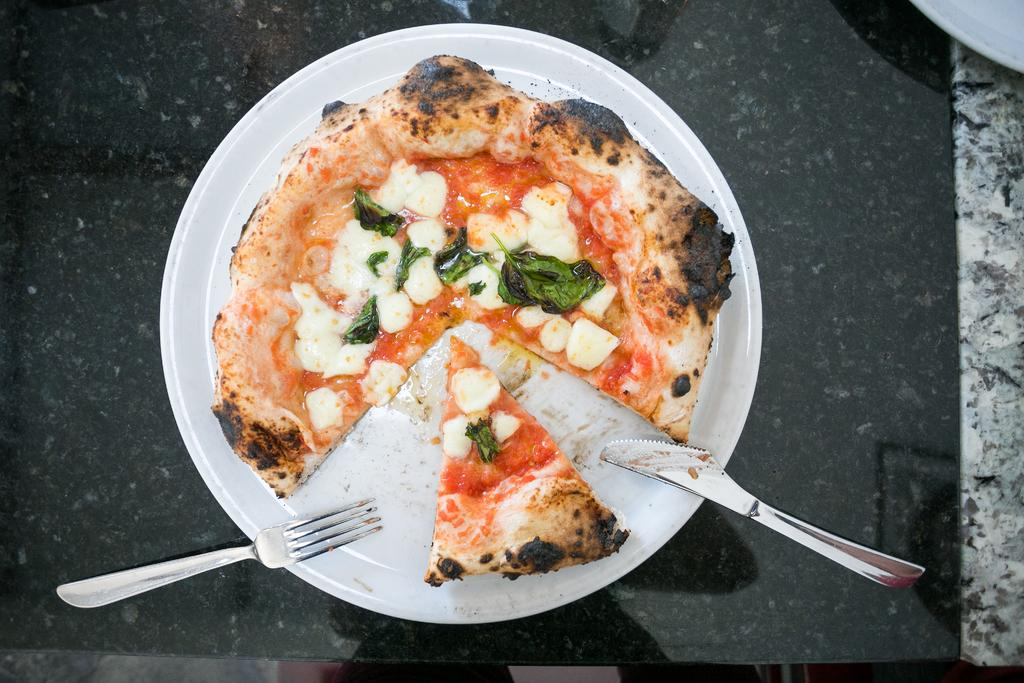What type of food is shown in the image? There is a pizza with leaves on it in the image. How is the pizza presented? The pizza is placed on a plate. What utensils are visible in the image? A fork and a knife are visible in the image. Where are the pizza and utensils located? The pizza and related items are placed on a table. What type of bushes can be seen growing around the pizza in the image? There are no bushes present in the image; it features a pizza with leaves on a plate. What type of ticket is required to eat the pizza in the image? There is no ticket or any indication of a requirement to eat the pizza in the image. 